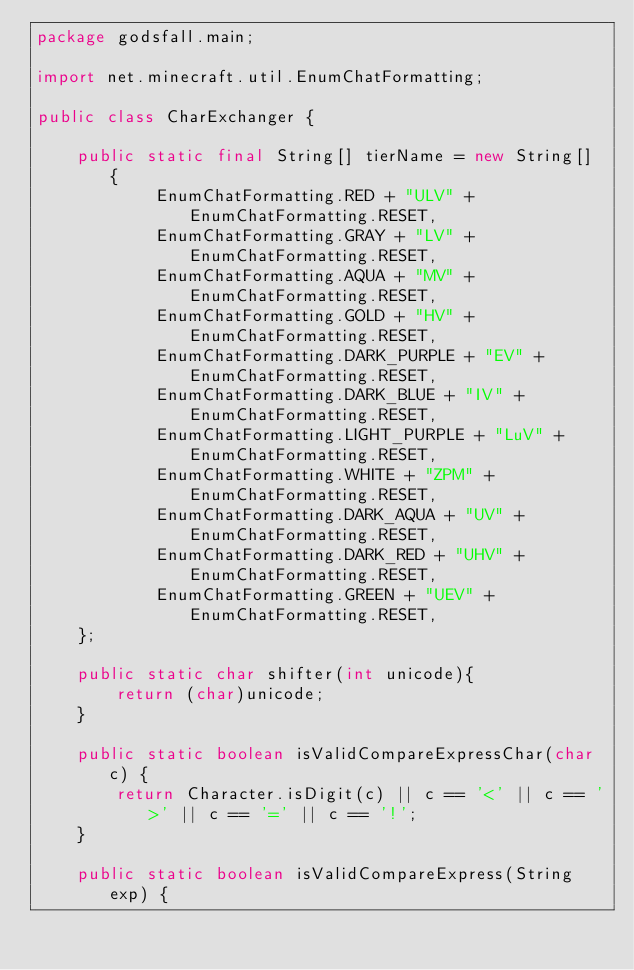<code> <loc_0><loc_0><loc_500><loc_500><_Java_>package godsfall.main;

import net.minecraft.util.EnumChatFormatting;

public class CharExchanger {

    public static final String[] tierName = new String[] {
            EnumChatFormatting.RED + "ULV" + EnumChatFormatting.RESET,
            EnumChatFormatting.GRAY + "LV" + EnumChatFormatting.RESET,
            EnumChatFormatting.AQUA + "MV" + EnumChatFormatting.RESET,
            EnumChatFormatting.GOLD + "HV" + EnumChatFormatting.RESET,
            EnumChatFormatting.DARK_PURPLE + "EV" + EnumChatFormatting.RESET,
            EnumChatFormatting.DARK_BLUE + "IV" + EnumChatFormatting.RESET,
            EnumChatFormatting.LIGHT_PURPLE + "LuV" + EnumChatFormatting.RESET,
            EnumChatFormatting.WHITE + "ZPM" + EnumChatFormatting.RESET,
            EnumChatFormatting.DARK_AQUA + "UV" + EnumChatFormatting.RESET,
            EnumChatFormatting.DARK_RED + "UHV" + EnumChatFormatting.RESET,
            EnumChatFormatting.GREEN + "UEV" + EnumChatFormatting.RESET,
    };

    public static char shifter(int unicode){
        return (char)unicode;
    }

    public static boolean isValidCompareExpressChar(char c) {
        return Character.isDigit(c) || c == '<' || c == '>' || c == '=' || c == '!';
    }

    public static boolean isValidCompareExpress(String exp) {</code> 